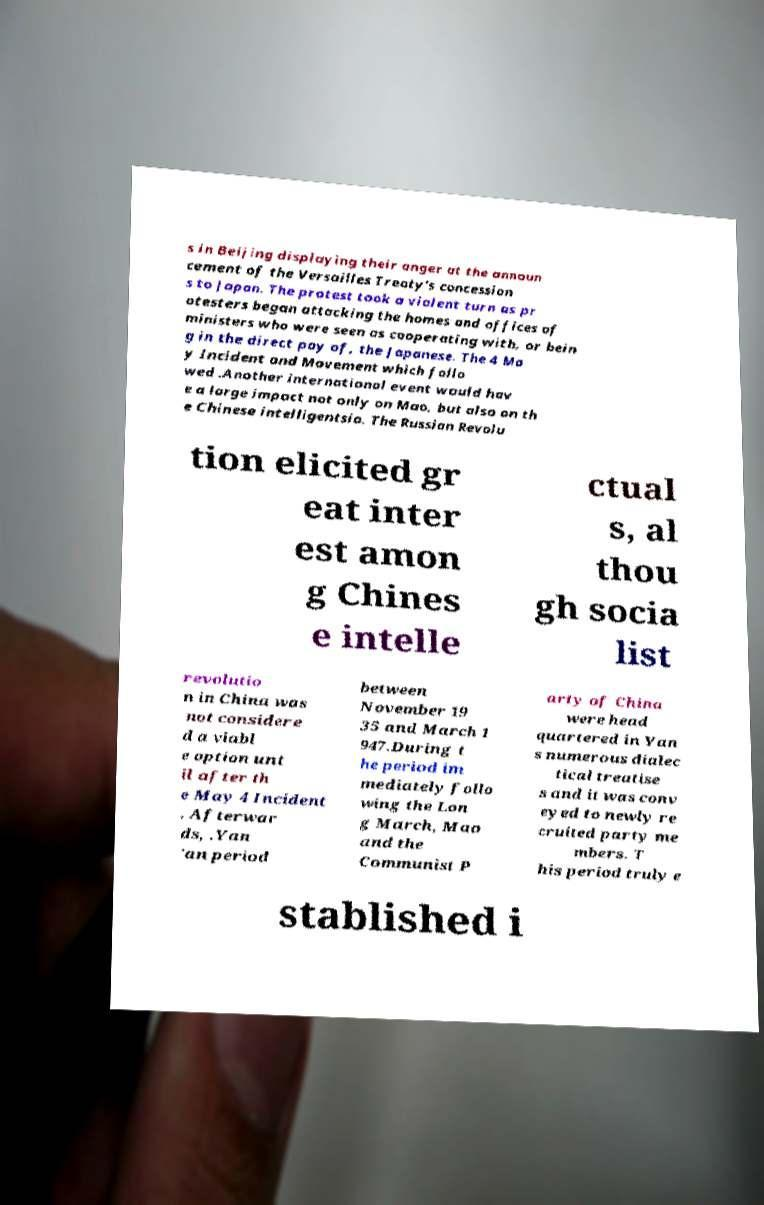Could you assist in decoding the text presented in this image and type it out clearly? s in Beijing displaying their anger at the announ cement of the Versailles Treaty's concession s to Japan. The protest took a violent turn as pr otesters began attacking the homes and offices of ministers who were seen as cooperating with, or bein g in the direct pay of, the Japanese. The 4 Ma y Incident and Movement which follo wed .Another international event would hav e a large impact not only on Mao, but also on th e Chinese intelligentsia. The Russian Revolu tion elicited gr eat inter est amon g Chines e intelle ctual s, al thou gh socia list revolutio n in China was not considere d a viabl e option unt il after th e May 4 Incident . Afterwar ds, .Yan 'an period between November 19 35 and March 1 947.During t he period im mediately follo wing the Lon g March, Mao and the Communist P arty of China were head quartered in Yan s numerous dialec tical treatise s and it was conv eyed to newly re cruited party me mbers. T his period truly e stablished i 